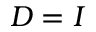Convert formula to latex. <formula><loc_0><loc_0><loc_500><loc_500>D = I</formula> 